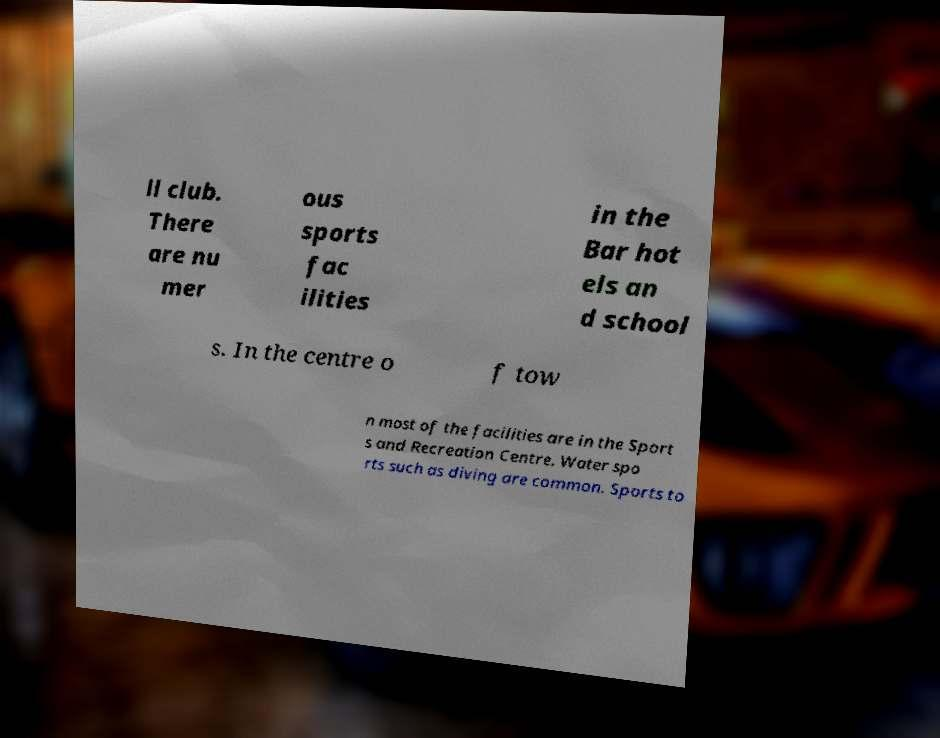There's text embedded in this image that I need extracted. Can you transcribe it verbatim? ll club. There are nu mer ous sports fac ilities in the Bar hot els an d school s. In the centre o f tow n most of the facilities are in the Sport s and Recreation Centre. Water spo rts such as diving are common. Sports to 